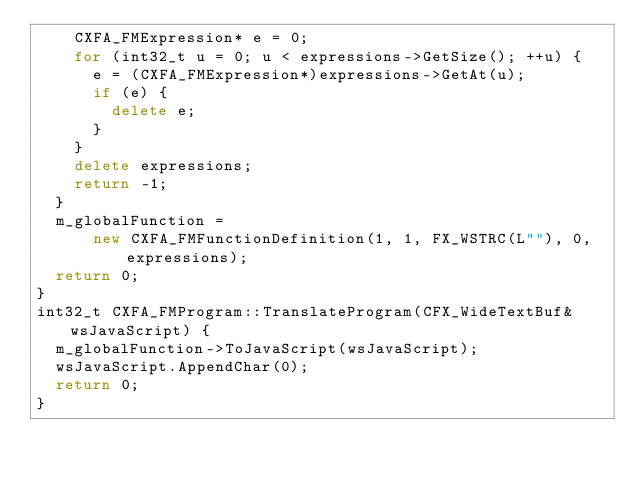<code> <loc_0><loc_0><loc_500><loc_500><_C++_>    CXFA_FMExpression* e = 0;
    for (int32_t u = 0; u < expressions->GetSize(); ++u) {
      e = (CXFA_FMExpression*)expressions->GetAt(u);
      if (e) {
        delete e;
      }
    }
    delete expressions;
    return -1;
  }
  m_globalFunction =
      new CXFA_FMFunctionDefinition(1, 1, FX_WSTRC(L""), 0, expressions);
  return 0;
}
int32_t CXFA_FMProgram::TranslateProgram(CFX_WideTextBuf& wsJavaScript) {
  m_globalFunction->ToJavaScript(wsJavaScript);
  wsJavaScript.AppendChar(0);
  return 0;
}
</code> 